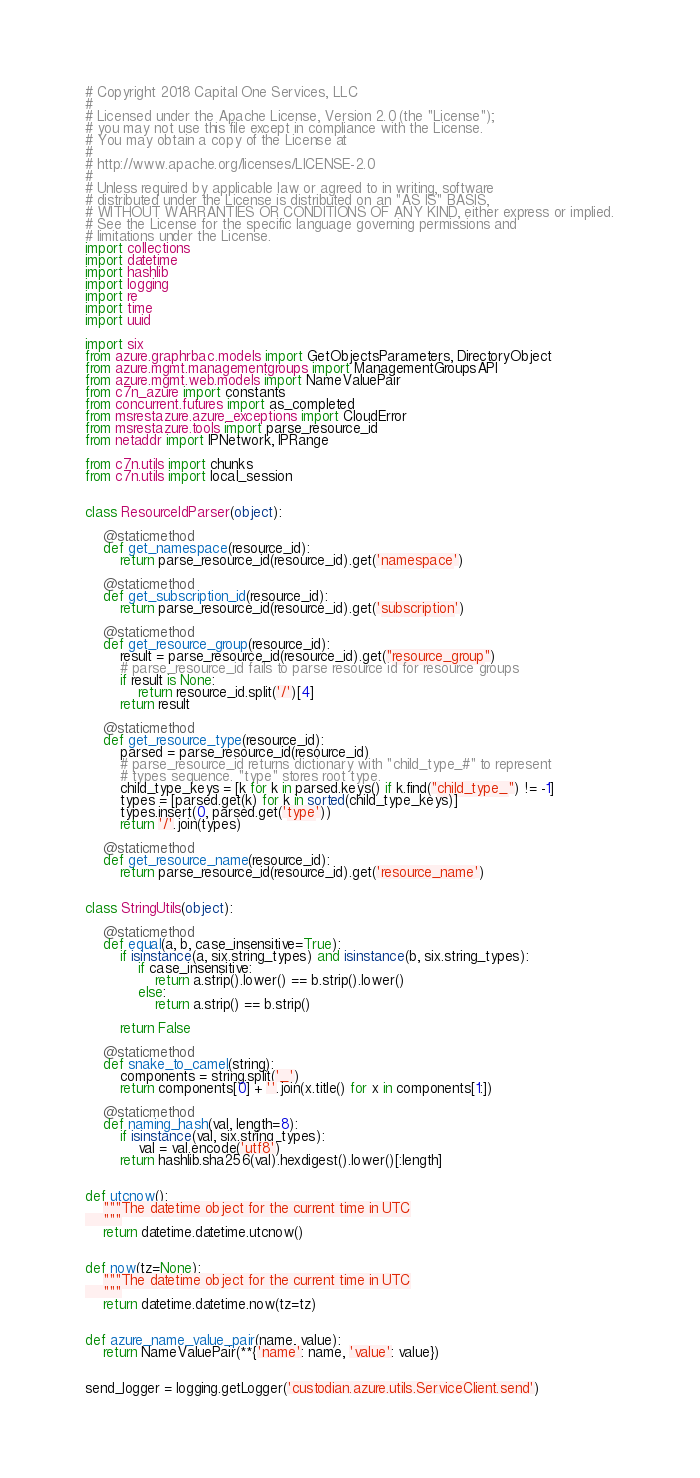<code> <loc_0><loc_0><loc_500><loc_500><_Python_># Copyright 2018 Capital One Services, LLC
#
# Licensed under the Apache License, Version 2.0 (the "License");
# you may not use this file except in compliance with the License.
# You may obtain a copy of the License at
#
# http://www.apache.org/licenses/LICENSE-2.0
#
# Unless required by applicable law or agreed to in writing, software
# distributed under the License is distributed on an "AS IS" BASIS,
# WITHOUT WARRANTIES OR CONDITIONS OF ANY KIND, either express or implied.
# See the License for the specific language governing permissions and
# limitations under the License.
import collections
import datetime
import hashlib
import logging
import re
import time
import uuid

import six
from azure.graphrbac.models import GetObjectsParameters, DirectoryObject
from azure.mgmt.managementgroups import ManagementGroupsAPI
from azure.mgmt.web.models import NameValuePair
from c7n_azure import constants
from concurrent.futures import as_completed
from msrestazure.azure_exceptions import CloudError
from msrestazure.tools import parse_resource_id
from netaddr import IPNetwork, IPRange

from c7n.utils import chunks
from c7n.utils import local_session


class ResourceIdParser(object):

    @staticmethod
    def get_namespace(resource_id):
        return parse_resource_id(resource_id).get('namespace')

    @staticmethod
    def get_subscription_id(resource_id):
        return parse_resource_id(resource_id).get('subscription')

    @staticmethod
    def get_resource_group(resource_id):
        result = parse_resource_id(resource_id).get("resource_group")
        # parse_resource_id fails to parse resource id for resource groups
        if result is None:
            return resource_id.split('/')[4]
        return result

    @staticmethod
    def get_resource_type(resource_id):
        parsed = parse_resource_id(resource_id)
        # parse_resource_id returns dictionary with "child_type_#" to represent
        # types sequence. "type" stores root type.
        child_type_keys = [k for k in parsed.keys() if k.find("child_type_") != -1]
        types = [parsed.get(k) for k in sorted(child_type_keys)]
        types.insert(0, parsed.get('type'))
        return '/'.join(types)

    @staticmethod
    def get_resource_name(resource_id):
        return parse_resource_id(resource_id).get('resource_name')


class StringUtils(object):

    @staticmethod
    def equal(a, b, case_insensitive=True):
        if isinstance(a, six.string_types) and isinstance(b, six.string_types):
            if case_insensitive:
                return a.strip().lower() == b.strip().lower()
            else:
                return a.strip() == b.strip()

        return False

    @staticmethod
    def snake_to_camel(string):
        components = string.split('_')
        return components[0] + ''.join(x.title() for x in components[1:])

    @staticmethod
    def naming_hash(val, length=8):
        if isinstance(val, six.string_types):
            val = val.encode('utf8')
        return hashlib.sha256(val).hexdigest().lower()[:length]


def utcnow():
    """The datetime object for the current time in UTC
    """
    return datetime.datetime.utcnow()


def now(tz=None):
    """The datetime object for the current time in UTC
    """
    return datetime.datetime.now(tz=tz)


def azure_name_value_pair(name, value):
    return NameValuePair(**{'name': name, 'value': value})


send_logger = logging.getLogger('custodian.azure.utils.ServiceClient.send')

</code> 